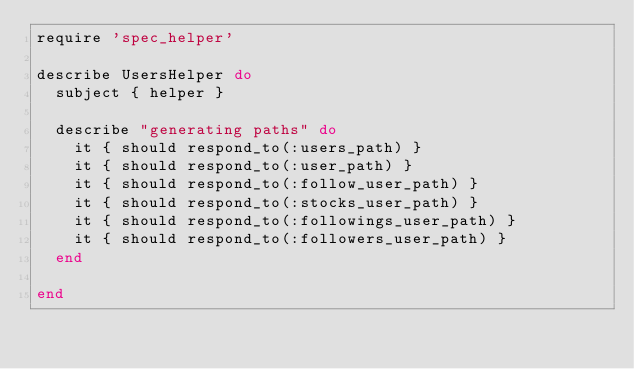Convert code to text. <code><loc_0><loc_0><loc_500><loc_500><_Ruby_>require 'spec_helper'

describe UsersHelper do
  subject { helper }

  describe "generating paths" do
    it { should respond_to(:users_path) }
    it { should respond_to(:user_path) }
    it { should respond_to(:follow_user_path) }
    it { should respond_to(:stocks_user_path) }
    it { should respond_to(:followings_user_path) }
    it { should respond_to(:followers_user_path) }
  end

end
</code> 